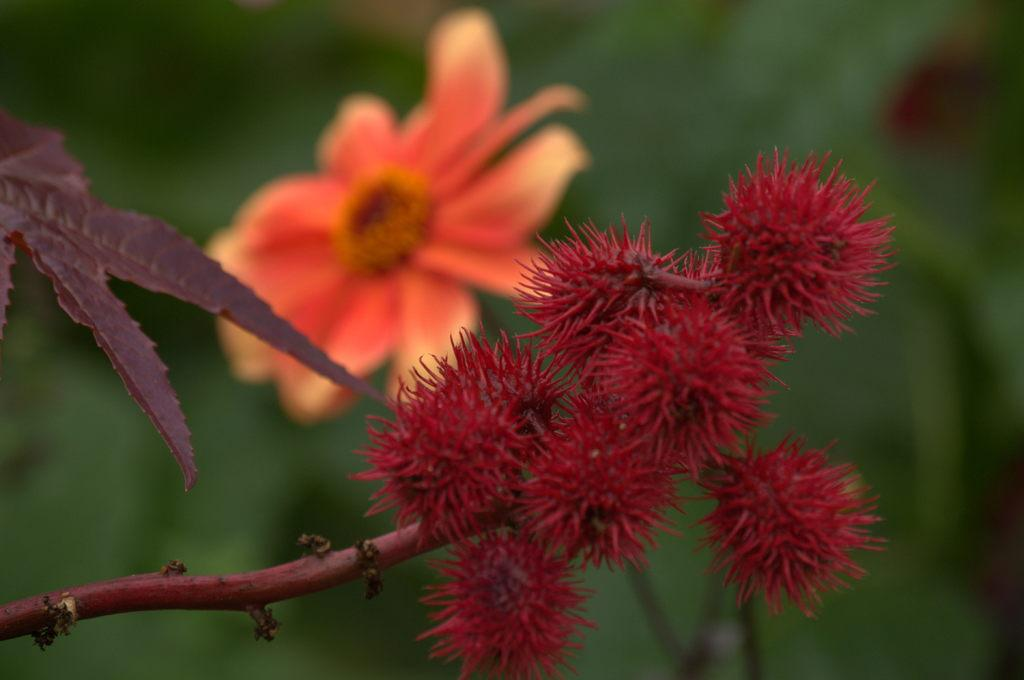What type of fruits are present in the image? There are rambutan fruits in the image. How are the fruits connected to each other? The fruits are attached to a stem. What can be seen on the left side of the image? There is a leaf on the left side of the image. What other plant element is visible in the image? There is a flower in the background of the image. How would you describe the background of the image? The background is blurred. How many patches can be seen on the man's shirt in the image? There is no man present in the image, so it is not possible to determine the number of patches on his shirt. 